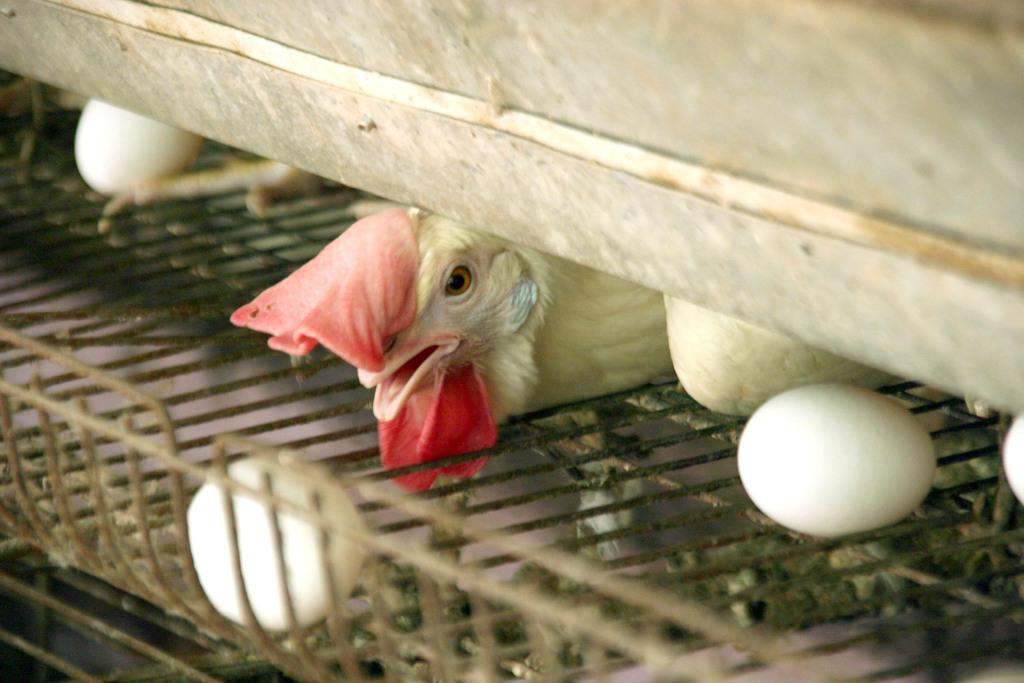What is present in the image that can be used for cooking or baking? There are eggs in the image that can be used for cooking or baking. Where are the eggs located in the image? The eggs are on a cage in the image. What other living creature can be seen in the image? There is a bird in the image. What type of force is being applied to the bird in the image? There is no force being applied to the bird in the image; it is simply present in the image. 